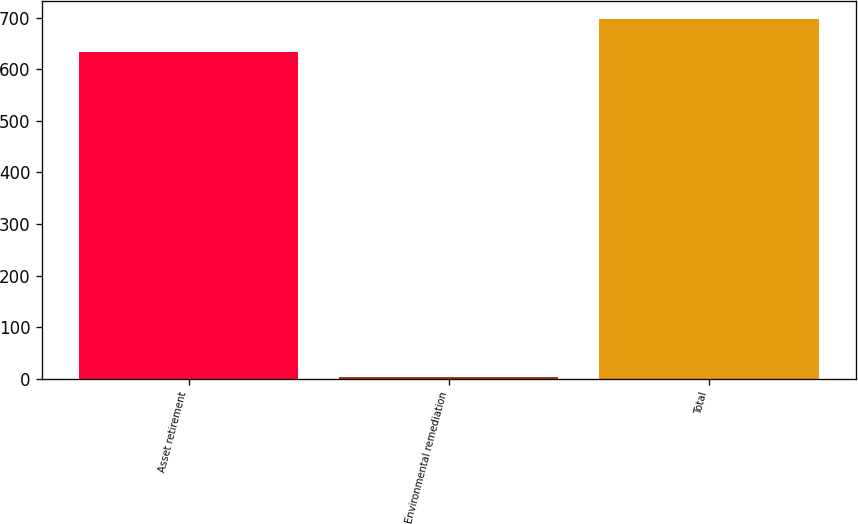Convert chart to OTSL. <chart><loc_0><loc_0><loc_500><loc_500><bar_chart><fcel>Asset retirement<fcel>Environmental remediation<fcel>Total<nl><fcel>634<fcel>4.7<fcel>697.4<nl></chart> 